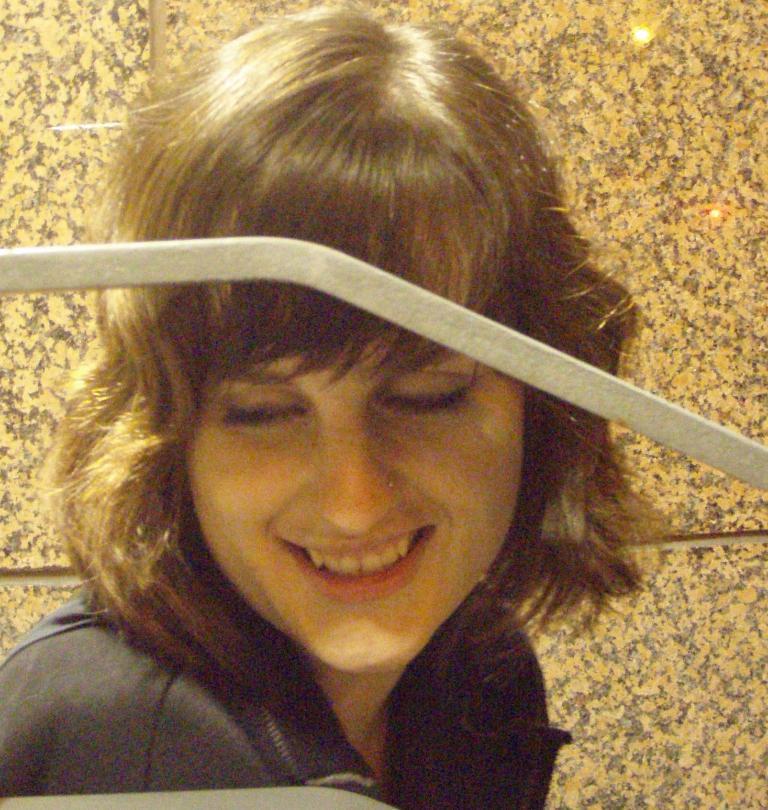In one or two sentences, can you explain what this image depicts? In this picture we can see a rod, women smiling and in the background we can see the wall. 